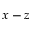Convert formula to latex. <formula><loc_0><loc_0><loc_500><loc_500>x - z</formula> 